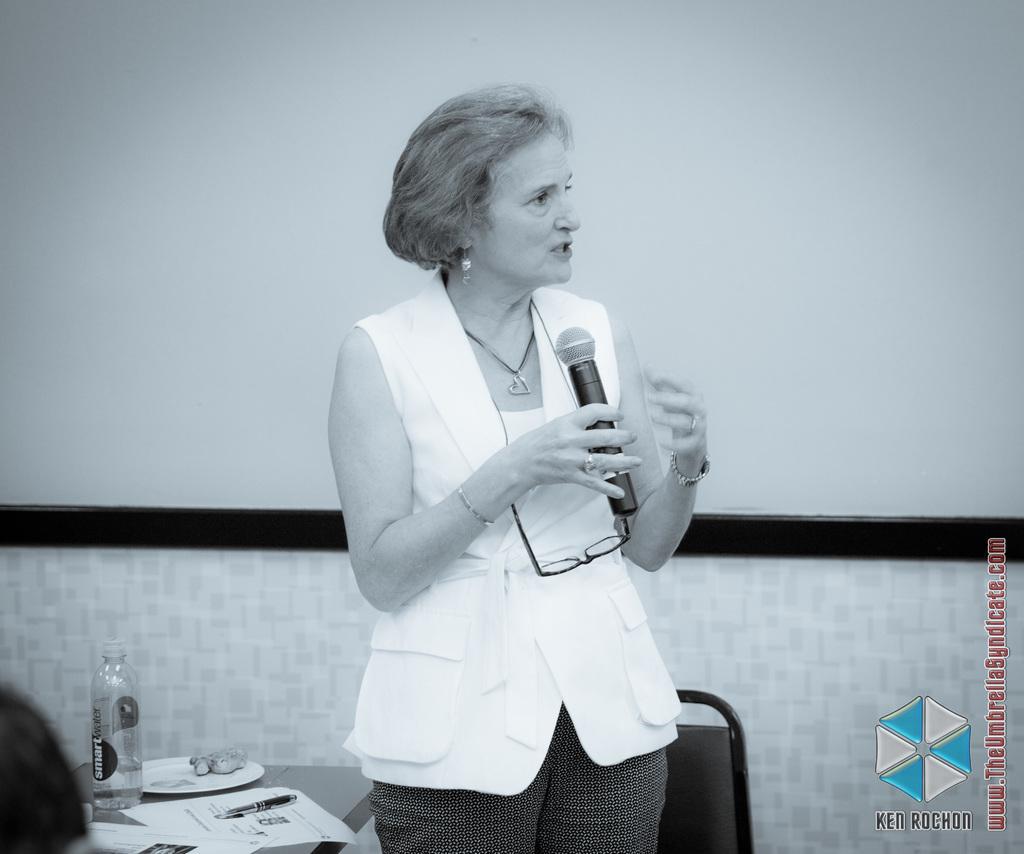Describe this image in one or two sentences. In this image I can see a woman who is standing and she is holding a mic and there is table side to her. In the background I can see the chair and the wall. 